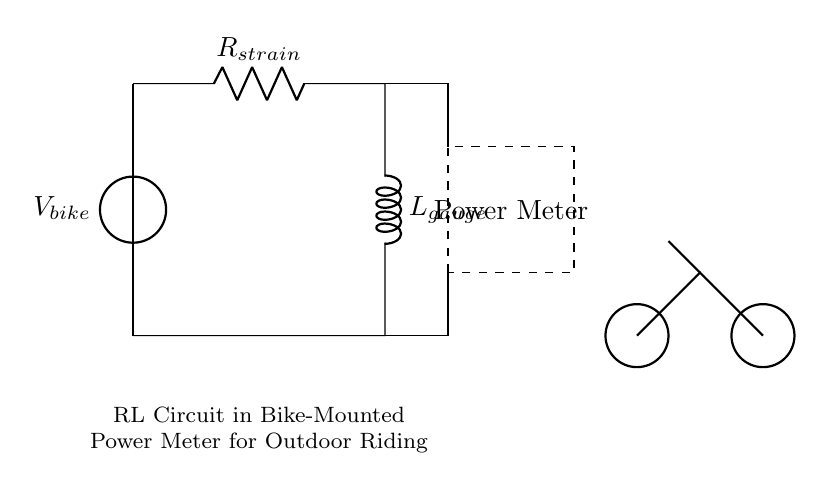What voltage source is represented in the circuit? The voltage source in the circuit is labeled as V_bike, which represents the power generated by the bike's motion.
Answer: V_bike What are the components in the RL circuit? The RL circuit consists of a resistor labeled R_strain and an inductor labeled L_gauge, both connected in series.
Answer: R_strain and L_gauge What role does the power meter play in this circuit? The power meter measures the electrical power generated by the RL circuit, indicated by the dashed rectangle in the diagram.
Answer: Measuring power How are the resistor and inductor connected in this circuit? The resistor and inductor are connected in series, meaning the current must pass through the resistor before reaching the inductor.
Answer: In series What effect does the inductor have on the circuit's performance? Inductors store energy in a magnetic field when current passes through them, which can influence the reaction to changes in current and helps manage power output.
Answer: Stores energy How does the voltage source relate to the RL circuit during cycling? The voltage source V_bike reflects the mechanical energy converted to electrical energy due to the motion of pedaling, which drives the current through the RL circuit.
Answer: Drives current What happens to current over time in this RL circuit? In an RL circuit, the current will increase over time exponentially, influenced by the inductor's ability to resist changes in current until it reaches a steady state.
Answer: Increases exponentially 